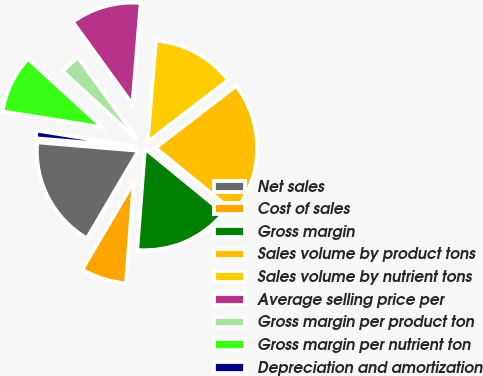<chart> <loc_0><loc_0><loc_500><loc_500><pie_chart><fcel>Net sales<fcel>Cost of sales<fcel>Gross margin<fcel>Sales volume by product tons<fcel>Sales volume by nutrient tons<fcel>Average selling price per<fcel>Gross margin per product ton<fcel>Gross margin per nutrient ton<fcel>Depreciation and amortization<nl><fcel>17.85%<fcel>7.25%<fcel>15.3%<fcel>21.33%<fcel>13.28%<fcel>11.27%<fcel>3.23%<fcel>9.26%<fcel>1.22%<nl></chart> 